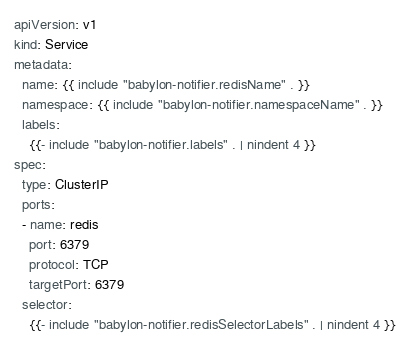<code> <loc_0><loc_0><loc_500><loc_500><_YAML_>apiVersion: v1
kind: Service
metadata:
  name: {{ include "babylon-notifier.redisName" . }}
  namespace: {{ include "babylon-notifier.namespaceName" . }}
  labels:
    {{- include "babylon-notifier.labels" . | nindent 4 }}
spec:
  type: ClusterIP
  ports:
  - name: redis
    port: 6379
    protocol: TCP
    targetPort: 6379
  selector:
    {{- include "babylon-notifier.redisSelectorLabels" . | nindent 4 }}
</code> 